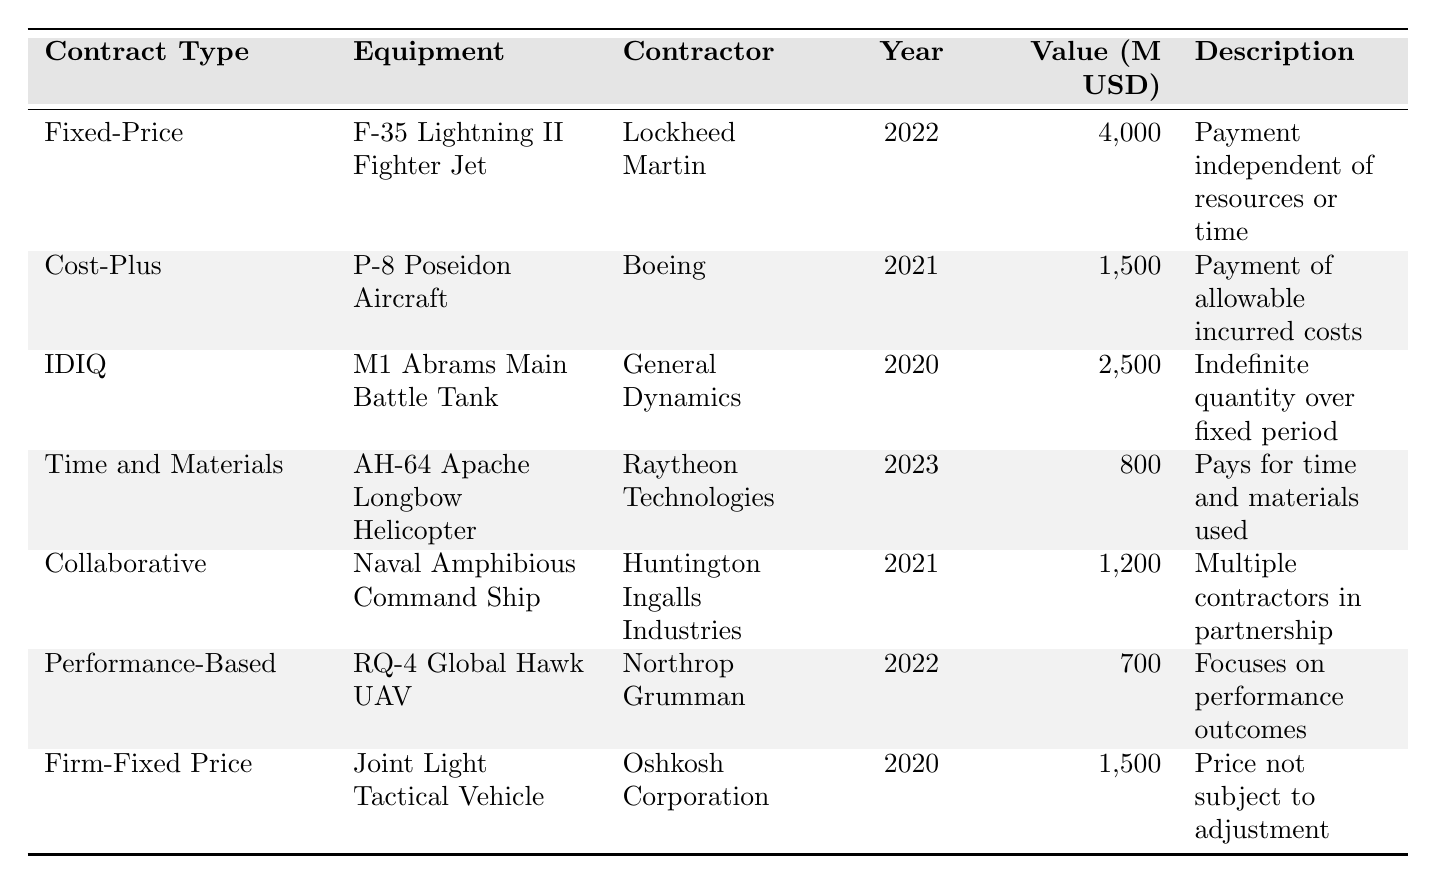What is the total value of the equipment procured under Fixed-Price Contracts? The table shows one entry under Fixed-Price Contracts with a total value of 4,000 million USD for the F-35 Lightning II Fighter Jet.
Answer: 4,000 million USD How many different contractors are listed in the table? The table lists 7 distinct contractors: Lockheed Martin, Boeing, General Dynamics, Raytheon Technologies, Huntington Ingalls Industries, Northrop Grumman, and Oshkosh Corporation. Thus, the total is 7.
Answer: 7 Which equipment was awarded under a Time and Materials Contract? The table indicates that the AH-64 Apache Longbow Helicopter was awarded under a Time and Materials Contract.
Answer: AH-64 Apache Longbow Helicopter What is the combined total value of the contracts awarded in 2021? For 2021, there are two contracts: P-8 Poseidon Aircraft worth 1,500 million USD and Naval Amphibious Command Ship worth 1,200 million USD. The combined total value is (1,500 + 1,200) = 2,700 million USD.
Answer: 2,700 million USD Is the RQ-4 Global Hawk UAV associated with a Cost-Plus Contract? The RQ-4 Global Hawk UAV is listed under a Performance-Based Contract, not a Cost-Plus Contract, so the answer is no.
Answer: No Which contractor has the highest total value contract? Lockheed Martin has the highest total value contract at 4,000 million USD for the F-35 Lightning II Fighter Jet.
Answer: Lockheed Martin What is the average total value of the contracts awarded for vehicles (considering only tanks and tactical vehicles)? The M1 Abrams Main Battle Tank has a value of 2,500 million USD and the Joint Light Tactical Vehicle has a value of 1,500 million USD. The average is (2,500 + 1,500) / 2 = 2,000 million USD.
Answer: 2,000 million USD Which type of contract involves multiple contractors working in partnership? The table specifies that the Collaborative Contract involves multiple contractors working in partnership, particularly for the Naval Amphibious Command Ship.
Answer: Collaborative Contract What is the total value of contracts awarded for aircraft? The total value of aircraft contracts includes the P-8 Poseidon Aircraft at 1,500 million USD and the RQ-4 Global Hawk UAV at 700 million USD. Thus, the total value is (1,500 + 700) = 2,200 million USD.
Answer: 2,200 million USD Did any contracts awarded in 2023 have a value greater than 1 billion USD? The only contract awarded in 2023 is the AH-64 Apache Longbow Helicopter, which has a value of 800 million USD, thus there are no contracts over 1 billion USD.
Answer: No 